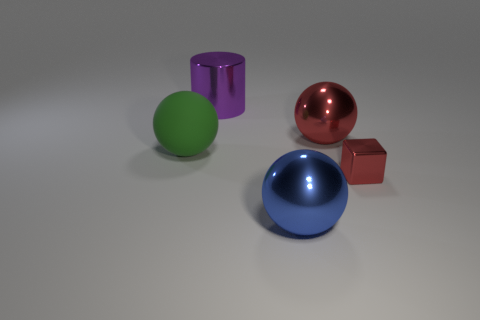Add 3 small things. How many objects exist? 8 Subtract all spheres. How many objects are left? 2 Add 4 metal objects. How many metal objects are left? 8 Add 5 metal things. How many metal things exist? 9 Subtract 0 yellow cylinders. How many objects are left? 5 Subtract all shiny objects. Subtract all big blue metallic spheres. How many objects are left? 0 